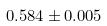Convert formula to latex. <formula><loc_0><loc_0><loc_500><loc_500>0 . 5 8 4 \pm 0 . 0 0 5</formula> 